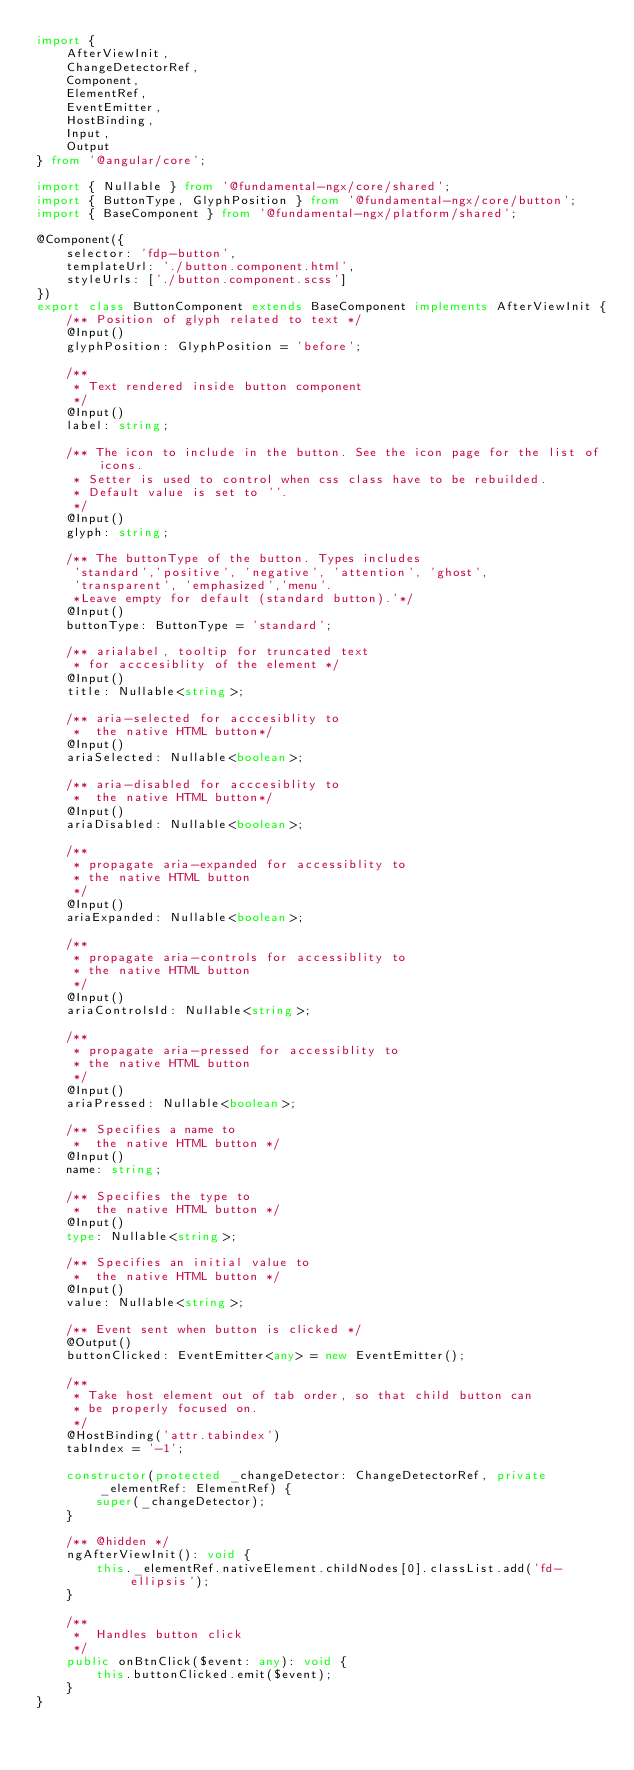<code> <loc_0><loc_0><loc_500><loc_500><_TypeScript_>import {
    AfterViewInit,
    ChangeDetectorRef,
    Component,
    ElementRef,
    EventEmitter,
    HostBinding,
    Input,
    Output
} from '@angular/core';

import { Nullable } from '@fundamental-ngx/core/shared';
import { ButtonType, GlyphPosition } from '@fundamental-ngx/core/button';
import { BaseComponent } from '@fundamental-ngx/platform/shared';

@Component({
    selector: 'fdp-button',
    templateUrl: './button.component.html',
    styleUrls: ['./button.component.scss']
})
export class ButtonComponent extends BaseComponent implements AfterViewInit {
    /** Position of glyph related to text */
    @Input()
    glyphPosition: GlyphPosition = 'before';

    /**
     * Text rendered inside button component
     */
    @Input()
    label: string;

    /** The icon to include in the button. See the icon page for the list of icons.
     * Setter is used to control when css class have to be rebuilded.
     * Default value is set to ''.
     */
    @Input()
    glyph: string;

    /** The buttonType of the button. Types includes
     'standard','positive', 'negative', 'attention', 'ghost',
     'transparent', 'emphasized','menu'.
     *Leave empty for default (standard button).'*/
    @Input()
    buttonType: ButtonType = 'standard';

    /** arialabel, tooltip for truncated text
     * for acccesiblity of the element */
    @Input()
    title: Nullable<string>;

    /** aria-selected for acccesiblity to
     *  the native HTML button*/
    @Input()
    ariaSelected: Nullable<boolean>;

    /** aria-disabled for acccesiblity to
     *  the native HTML button*/
    @Input()
    ariaDisabled: Nullable<boolean>;

    /**
     * propagate aria-expanded for accessiblity to
     * the native HTML button
     */
    @Input()
    ariaExpanded: Nullable<boolean>;

    /**
     * propagate aria-controls for accessiblity to
     * the native HTML button
     */
    @Input()
    ariaControlsId: Nullable<string>;

    /**
     * propagate aria-pressed for accessiblity to
     * the native HTML button
     */
    @Input()
    ariaPressed: Nullable<boolean>;

    /** Specifies a name to
     *  the native HTML button */
    @Input()
    name: string;

    /** Specifies the type to
     *  the native HTML button */
    @Input()
    type: Nullable<string>;

    /** Specifies an initial value to
     *  the native HTML button */
    @Input()
    value: Nullable<string>;

    /** Event sent when button is clicked */
    @Output()
    buttonClicked: EventEmitter<any> = new EventEmitter();

    /**
     * Take host element out of tab order, so that child button can
     * be properly focused on.
     */
    @HostBinding('attr.tabindex')
    tabIndex = '-1';

    constructor(protected _changeDetector: ChangeDetectorRef, private _elementRef: ElementRef) {
        super(_changeDetector);
    }

    /** @hidden */
    ngAfterViewInit(): void {
        this._elementRef.nativeElement.childNodes[0].classList.add('fd-ellipsis');
    }

    /**
     *  Handles button click
     */
    public onBtnClick($event: any): void {
        this.buttonClicked.emit($event);
    }
}
</code> 